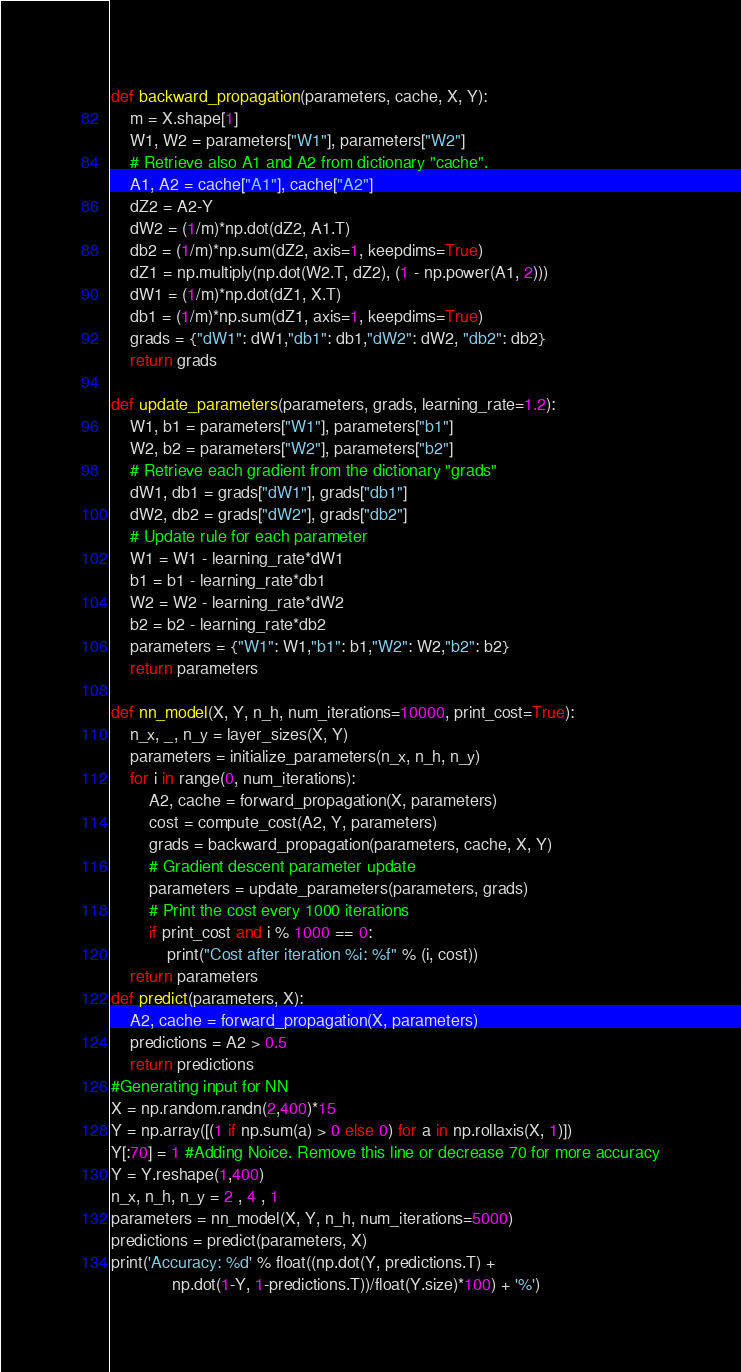<code> <loc_0><loc_0><loc_500><loc_500><_Python_>def backward_propagation(parameters, cache, X, Y):
    m = X.shape[1]
    W1, W2 = parameters["W1"], parameters["W2"]
    # Retrieve also A1 and A2 from dictionary "cache".
    A1, A2 = cache["A1"], cache["A2"]
    dZ2 = A2-Y
    dW2 = (1/m)*np.dot(dZ2, A1.T)
    db2 = (1/m)*np.sum(dZ2, axis=1, keepdims=True)
    dZ1 = np.multiply(np.dot(W2.T, dZ2), (1 - np.power(A1, 2)))
    dW1 = (1/m)*np.dot(dZ1, X.T)
    db1 = (1/m)*np.sum(dZ1, axis=1, keepdims=True)
    grads = {"dW1": dW1,"db1": db1,"dW2": dW2, "db2": db2}
    return grads

def update_parameters(parameters, grads, learning_rate=1.2):
    W1, b1 = parameters["W1"], parameters["b1"]
    W2, b2 = parameters["W2"], parameters["b2"]
    # Retrieve each gradient from the dictionary "grads"
    dW1, db1 = grads["dW1"], grads["db1"]
    dW2, db2 = grads["dW2"], grads["db2"]
    # Update rule for each parameter
    W1 = W1 - learning_rate*dW1
    b1 = b1 - learning_rate*db1
    W2 = W2 - learning_rate*dW2
    b2 = b2 - learning_rate*db2
    parameters = {"W1": W1,"b1": b1,"W2": W2,"b2": b2}
    return parameters

def nn_model(X, Y, n_h, num_iterations=10000, print_cost=True):
    n_x, _, n_y = layer_sizes(X, Y)
    parameters = initialize_parameters(n_x, n_h, n_y)
    for i in range(0, num_iterations):
        A2, cache = forward_propagation(X, parameters)
        cost = compute_cost(A2, Y, parameters)
        grads = backward_propagation(parameters, cache, X, Y)
        # Gradient descent parameter update
        parameters = update_parameters(parameters, grads)
        # Print the cost every 1000 iterations
        if print_cost and i % 1000 == 0:
            print("Cost after iteration %i: %f" % (i, cost))
    return parameters
def predict(parameters, X):
    A2, cache = forward_propagation(X, parameters)
    predictions = A2 > 0.5
    return predictions
#Generating input for NN
X = np.random.randn(2,400)*15
Y = np.array([(1 if np.sum(a) > 0 else 0) for a in np.rollaxis(X, 1)])
Y[:70] = 1 #Adding Noice. Remove this line or decrease 70 for more accuracy
Y = Y.reshape(1,400)
n_x, n_h, n_y = 2 , 4 , 1
parameters = nn_model(X, Y, n_h, num_iterations=5000)
predictions = predict(parameters, X)
print('Accuracy: %d' % float((np.dot(Y, predictions.T) +
             np.dot(1-Y, 1-predictions.T))/float(Y.size)*100) + '%')</code> 